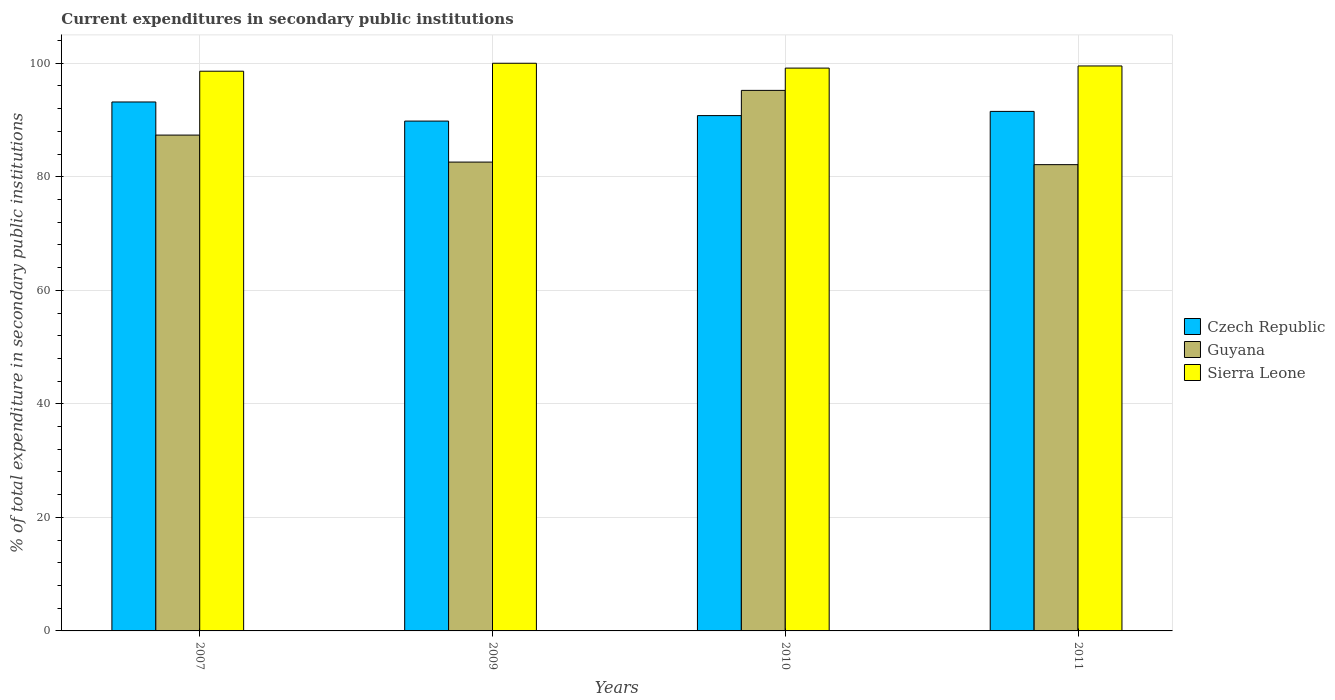How many different coloured bars are there?
Keep it short and to the point. 3. How many groups of bars are there?
Your answer should be very brief. 4. Are the number of bars on each tick of the X-axis equal?
Keep it short and to the point. Yes. How many bars are there on the 3rd tick from the left?
Offer a terse response. 3. How many bars are there on the 4th tick from the right?
Provide a short and direct response. 3. What is the label of the 4th group of bars from the left?
Your answer should be very brief. 2011. What is the current expenditures in secondary public institutions in Guyana in 2010?
Your answer should be compact. 95.22. Across all years, what is the maximum current expenditures in secondary public institutions in Guyana?
Provide a short and direct response. 95.22. Across all years, what is the minimum current expenditures in secondary public institutions in Czech Republic?
Your response must be concise. 89.81. What is the total current expenditures in secondary public institutions in Sierra Leone in the graph?
Provide a succinct answer. 397.27. What is the difference between the current expenditures in secondary public institutions in Guyana in 2007 and that in 2009?
Offer a very short reply. 4.76. What is the difference between the current expenditures in secondary public institutions in Sierra Leone in 2007 and the current expenditures in secondary public institutions in Guyana in 2010?
Your answer should be very brief. 3.38. What is the average current expenditures in secondary public institutions in Czech Republic per year?
Provide a short and direct response. 91.32. In the year 2009, what is the difference between the current expenditures in secondary public institutions in Guyana and current expenditures in secondary public institutions in Czech Republic?
Offer a very short reply. -7.22. What is the ratio of the current expenditures in secondary public institutions in Czech Republic in 2007 to that in 2010?
Your answer should be compact. 1.03. Is the current expenditures in secondary public institutions in Guyana in 2007 less than that in 2010?
Offer a terse response. Yes. Is the difference between the current expenditures in secondary public institutions in Guyana in 2007 and 2011 greater than the difference between the current expenditures in secondary public institutions in Czech Republic in 2007 and 2011?
Your answer should be compact. Yes. What is the difference between the highest and the second highest current expenditures in secondary public institutions in Czech Republic?
Provide a short and direct response. 1.66. What is the difference between the highest and the lowest current expenditures in secondary public institutions in Czech Republic?
Provide a succinct answer. 3.37. Is the sum of the current expenditures in secondary public institutions in Guyana in 2007 and 2010 greater than the maximum current expenditures in secondary public institutions in Czech Republic across all years?
Your response must be concise. Yes. What does the 3rd bar from the left in 2009 represents?
Your answer should be compact. Sierra Leone. What does the 2nd bar from the right in 2010 represents?
Make the answer very short. Guyana. Is it the case that in every year, the sum of the current expenditures in secondary public institutions in Guyana and current expenditures in secondary public institutions in Sierra Leone is greater than the current expenditures in secondary public institutions in Czech Republic?
Your answer should be compact. Yes. Are all the bars in the graph horizontal?
Your answer should be very brief. No. How many years are there in the graph?
Keep it short and to the point. 4. What is the difference between two consecutive major ticks on the Y-axis?
Ensure brevity in your answer.  20. Are the values on the major ticks of Y-axis written in scientific E-notation?
Keep it short and to the point. No. Does the graph contain any zero values?
Offer a very short reply. No. Does the graph contain grids?
Your response must be concise. Yes. Where does the legend appear in the graph?
Provide a short and direct response. Center right. How many legend labels are there?
Ensure brevity in your answer.  3. What is the title of the graph?
Provide a short and direct response. Current expenditures in secondary public institutions. What is the label or title of the Y-axis?
Your answer should be very brief. % of total expenditure in secondary public institutions. What is the % of total expenditure in secondary public institutions of Czech Republic in 2007?
Provide a short and direct response. 93.18. What is the % of total expenditure in secondary public institutions of Guyana in 2007?
Your response must be concise. 87.35. What is the % of total expenditure in secondary public institutions in Sierra Leone in 2007?
Your answer should be compact. 98.6. What is the % of total expenditure in secondary public institutions of Czech Republic in 2009?
Provide a short and direct response. 89.81. What is the % of total expenditure in secondary public institutions of Guyana in 2009?
Provide a succinct answer. 82.59. What is the % of total expenditure in secondary public institutions in Czech Republic in 2010?
Your answer should be compact. 90.78. What is the % of total expenditure in secondary public institutions of Guyana in 2010?
Provide a short and direct response. 95.22. What is the % of total expenditure in secondary public institutions of Sierra Leone in 2010?
Your response must be concise. 99.15. What is the % of total expenditure in secondary public institutions of Czech Republic in 2011?
Offer a terse response. 91.52. What is the % of total expenditure in secondary public institutions in Guyana in 2011?
Ensure brevity in your answer.  82.14. What is the % of total expenditure in secondary public institutions in Sierra Leone in 2011?
Offer a terse response. 99.52. Across all years, what is the maximum % of total expenditure in secondary public institutions in Czech Republic?
Offer a terse response. 93.18. Across all years, what is the maximum % of total expenditure in secondary public institutions in Guyana?
Your answer should be very brief. 95.22. Across all years, what is the maximum % of total expenditure in secondary public institutions of Sierra Leone?
Offer a very short reply. 100. Across all years, what is the minimum % of total expenditure in secondary public institutions of Czech Republic?
Offer a very short reply. 89.81. Across all years, what is the minimum % of total expenditure in secondary public institutions in Guyana?
Provide a short and direct response. 82.14. Across all years, what is the minimum % of total expenditure in secondary public institutions in Sierra Leone?
Your answer should be compact. 98.6. What is the total % of total expenditure in secondary public institutions of Czech Republic in the graph?
Your answer should be very brief. 365.29. What is the total % of total expenditure in secondary public institutions in Guyana in the graph?
Give a very brief answer. 347.3. What is the total % of total expenditure in secondary public institutions in Sierra Leone in the graph?
Your answer should be compact. 397.27. What is the difference between the % of total expenditure in secondary public institutions in Czech Republic in 2007 and that in 2009?
Keep it short and to the point. 3.37. What is the difference between the % of total expenditure in secondary public institutions in Guyana in 2007 and that in 2009?
Give a very brief answer. 4.76. What is the difference between the % of total expenditure in secondary public institutions in Sierra Leone in 2007 and that in 2009?
Give a very brief answer. -1.4. What is the difference between the % of total expenditure in secondary public institutions of Czech Republic in 2007 and that in 2010?
Provide a succinct answer. 2.4. What is the difference between the % of total expenditure in secondary public institutions of Guyana in 2007 and that in 2010?
Provide a succinct answer. -7.87. What is the difference between the % of total expenditure in secondary public institutions of Sierra Leone in 2007 and that in 2010?
Offer a very short reply. -0.55. What is the difference between the % of total expenditure in secondary public institutions of Czech Republic in 2007 and that in 2011?
Offer a very short reply. 1.66. What is the difference between the % of total expenditure in secondary public institutions of Guyana in 2007 and that in 2011?
Your answer should be very brief. 5.21. What is the difference between the % of total expenditure in secondary public institutions in Sierra Leone in 2007 and that in 2011?
Your answer should be compact. -0.92. What is the difference between the % of total expenditure in secondary public institutions of Czech Republic in 2009 and that in 2010?
Your answer should be compact. -0.97. What is the difference between the % of total expenditure in secondary public institutions in Guyana in 2009 and that in 2010?
Offer a terse response. -12.63. What is the difference between the % of total expenditure in secondary public institutions of Sierra Leone in 2009 and that in 2010?
Your answer should be very brief. 0.85. What is the difference between the % of total expenditure in secondary public institutions in Czech Republic in 2009 and that in 2011?
Ensure brevity in your answer.  -1.71. What is the difference between the % of total expenditure in secondary public institutions of Guyana in 2009 and that in 2011?
Provide a short and direct response. 0.45. What is the difference between the % of total expenditure in secondary public institutions in Sierra Leone in 2009 and that in 2011?
Your answer should be very brief. 0.48. What is the difference between the % of total expenditure in secondary public institutions in Czech Republic in 2010 and that in 2011?
Offer a very short reply. -0.74. What is the difference between the % of total expenditure in secondary public institutions of Guyana in 2010 and that in 2011?
Provide a succinct answer. 13.08. What is the difference between the % of total expenditure in secondary public institutions of Sierra Leone in 2010 and that in 2011?
Your answer should be compact. -0.38. What is the difference between the % of total expenditure in secondary public institutions of Czech Republic in 2007 and the % of total expenditure in secondary public institutions of Guyana in 2009?
Ensure brevity in your answer.  10.59. What is the difference between the % of total expenditure in secondary public institutions of Czech Republic in 2007 and the % of total expenditure in secondary public institutions of Sierra Leone in 2009?
Provide a succinct answer. -6.82. What is the difference between the % of total expenditure in secondary public institutions in Guyana in 2007 and the % of total expenditure in secondary public institutions in Sierra Leone in 2009?
Offer a very short reply. -12.65. What is the difference between the % of total expenditure in secondary public institutions of Czech Republic in 2007 and the % of total expenditure in secondary public institutions of Guyana in 2010?
Your response must be concise. -2.04. What is the difference between the % of total expenditure in secondary public institutions of Czech Republic in 2007 and the % of total expenditure in secondary public institutions of Sierra Leone in 2010?
Your response must be concise. -5.97. What is the difference between the % of total expenditure in secondary public institutions in Guyana in 2007 and the % of total expenditure in secondary public institutions in Sierra Leone in 2010?
Offer a very short reply. -11.8. What is the difference between the % of total expenditure in secondary public institutions in Czech Republic in 2007 and the % of total expenditure in secondary public institutions in Guyana in 2011?
Ensure brevity in your answer.  11.04. What is the difference between the % of total expenditure in secondary public institutions of Czech Republic in 2007 and the % of total expenditure in secondary public institutions of Sierra Leone in 2011?
Provide a short and direct response. -6.34. What is the difference between the % of total expenditure in secondary public institutions in Guyana in 2007 and the % of total expenditure in secondary public institutions in Sierra Leone in 2011?
Offer a terse response. -12.18. What is the difference between the % of total expenditure in secondary public institutions of Czech Republic in 2009 and the % of total expenditure in secondary public institutions of Guyana in 2010?
Your answer should be very brief. -5.41. What is the difference between the % of total expenditure in secondary public institutions of Czech Republic in 2009 and the % of total expenditure in secondary public institutions of Sierra Leone in 2010?
Your response must be concise. -9.33. What is the difference between the % of total expenditure in secondary public institutions of Guyana in 2009 and the % of total expenditure in secondary public institutions of Sierra Leone in 2010?
Offer a very short reply. -16.56. What is the difference between the % of total expenditure in secondary public institutions in Czech Republic in 2009 and the % of total expenditure in secondary public institutions in Guyana in 2011?
Offer a terse response. 7.67. What is the difference between the % of total expenditure in secondary public institutions in Czech Republic in 2009 and the % of total expenditure in secondary public institutions in Sierra Leone in 2011?
Ensure brevity in your answer.  -9.71. What is the difference between the % of total expenditure in secondary public institutions of Guyana in 2009 and the % of total expenditure in secondary public institutions of Sierra Leone in 2011?
Give a very brief answer. -16.93. What is the difference between the % of total expenditure in secondary public institutions in Czech Republic in 2010 and the % of total expenditure in secondary public institutions in Guyana in 2011?
Provide a succinct answer. 8.64. What is the difference between the % of total expenditure in secondary public institutions of Czech Republic in 2010 and the % of total expenditure in secondary public institutions of Sierra Leone in 2011?
Your answer should be very brief. -8.74. What is the difference between the % of total expenditure in secondary public institutions in Guyana in 2010 and the % of total expenditure in secondary public institutions in Sierra Leone in 2011?
Ensure brevity in your answer.  -4.3. What is the average % of total expenditure in secondary public institutions of Czech Republic per year?
Your answer should be compact. 91.32. What is the average % of total expenditure in secondary public institutions of Guyana per year?
Offer a terse response. 86.82. What is the average % of total expenditure in secondary public institutions in Sierra Leone per year?
Provide a succinct answer. 99.32. In the year 2007, what is the difference between the % of total expenditure in secondary public institutions of Czech Republic and % of total expenditure in secondary public institutions of Guyana?
Provide a succinct answer. 5.83. In the year 2007, what is the difference between the % of total expenditure in secondary public institutions of Czech Republic and % of total expenditure in secondary public institutions of Sierra Leone?
Your answer should be compact. -5.42. In the year 2007, what is the difference between the % of total expenditure in secondary public institutions in Guyana and % of total expenditure in secondary public institutions in Sierra Leone?
Provide a short and direct response. -11.25. In the year 2009, what is the difference between the % of total expenditure in secondary public institutions in Czech Republic and % of total expenditure in secondary public institutions in Guyana?
Your response must be concise. 7.22. In the year 2009, what is the difference between the % of total expenditure in secondary public institutions of Czech Republic and % of total expenditure in secondary public institutions of Sierra Leone?
Ensure brevity in your answer.  -10.19. In the year 2009, what is the difference between the % of total expenditure in secondary public institutions in Guyana and % of total expenditure in secondary public institutions in Sierra Leone?
Provide a succinct answer. -17.41. In the year 2010, what is the difference between the % of total expenditure in secondary public institutions in Czech Republic and % of total expenditure in secondary public institutions in Guyana?
Keep it short and to the point. -4.44. In the year 2010, what is the difference between the % of total expenditure in secondary public institutions in Czech Republic and % of total expenditure in secondary public institutions in Sierra Leone?
Provide a short and direct response. -8.37. In the year 2010, what is the difference between the % of total expenditure in secondary public institutions in Guyana and % of total expenditure in secondary public institutions in Sierra Leone?
Make the answer very short. -3.93. In the year 2011, what is the difference between the % of total expenditure in secondary public institutions of Czech Republic and % of total expenditure in secondary public institutions of Guyana?
Offer a terse response. 9.38. In the year 2011, what is the difference between the % of total expenditure in secondary public institutions of Czech Republic and % of total expenditure in secondary public institutions of Sierra Leone?
Offer a very short reply. -8. In the year 2011, what is the difference between the % of total expenditure in secondary public institutions in Guyana and % of total expenditure in secondary public institutions in Sierra Leone?
Ensure brevity in your answer.  -17.38. What is the ratio of the % of total expenditure in secondary public institutions of Czech Republic in 2007 to that in 2009?
Offer a very short reply. 1.04. What is the ratio of the % of total expenditure in secondary public institutions in Guyana in 2007 to that in 2009?
Make the answer very short. 1.06. What is the ratio of the % of total expenditure in secondary public institutions of Czech Republic in 2007 to that in 2010?
Offer a very short reply. 1.03. What is the ratio of the % of total expenditure in secondary public institutions in Guyana in 2007 to that in 2010?
Give a very brief answer. 0.92. What is the ratio of the % of total expenditure in secondary public institutions in Sierra Leone in 2007 to that in 2010?
Make the answer very short. 0.99. What is the ratio of the % of total expenditure in secondary public institutions in Czech Republic in 2007 to that in 2011?
Your response must be concise. 1.02. What is the ratio of the % of total expenditure in secondary public institutions in Guyana in 2007 to that in 2011?
Provide a succinct answer. 1.06. What is the ratio of the % of total expenditure in secondary public institutions of Sierra Leone in 2007 to that in 2011?
Offer a very short reply. 0.99. What is the ratio of the % of total expenditure in secondary public institutions of Czech Republic in 2009 to that in 2010?
Your answer should be very brief. 0.99. What is the ratio of the % of total expenditure in secondary public institutions in Guyana in 2009 to that in 2010?
Provide a succinct answer. 0.87. What is the ratio of the % of total expenditure in secondary public institutions of Sierra Leone in 2009 to that in 2010?
Ensure brevity in your answer.  1.01. What is the ratio of the % of total expenditure in secondary public institutions of Czech Republic in 2009 to that in 2011?
Provide a short and direct response. 0.98. What is the ratio of the % of total expenditure in secondary public institutions of Guyana in 2009 to that in 2011?
Keep it short and to the point. 1.01. What is the ratio of the % of total expenditure in secondary public institutions in Sierra Leone in 2009 to that in 2011?
Your answer should be compact. 1. What is the ratio of the % of total expenditure in secondary public institutions in Czech Republic in 2010 to that in 2011?
Provide a short and direct response. 0.99. What is the ratio of the % of total expenditure in secondary public institutions in Guyana in 2010 to that in 2011?
Your answer should be compact. 1.16. What is the difference between the highest and the second highest % of total expenditure in secondary public institutions of Czech Republic?
Offer a terse response. 1.66. What is the difference between the highest and the second highest % of total expenditure in secondary public institutions of Guyana?
Make the answer very short. 7.87. What is the difference between the highest and the second highest % of total expenditure in secondary public institutions in Sierra Leone?
Your answer should be very brief. 0.48. What is the difference between the highest and the lowest % of total expenditure in secondary public institutions in Czech Republic?
Offer a very short reply. 3.37. What is the difference between the highest and the lowest % of total expenditure in secondary public institutions in Guyana?
Make the answer very short. 13.08. What is the difference between the highest and the lowest % of total expenditure in secondary public institutions in Sierra Leone?
Keep it short and to the point. 1.4. 